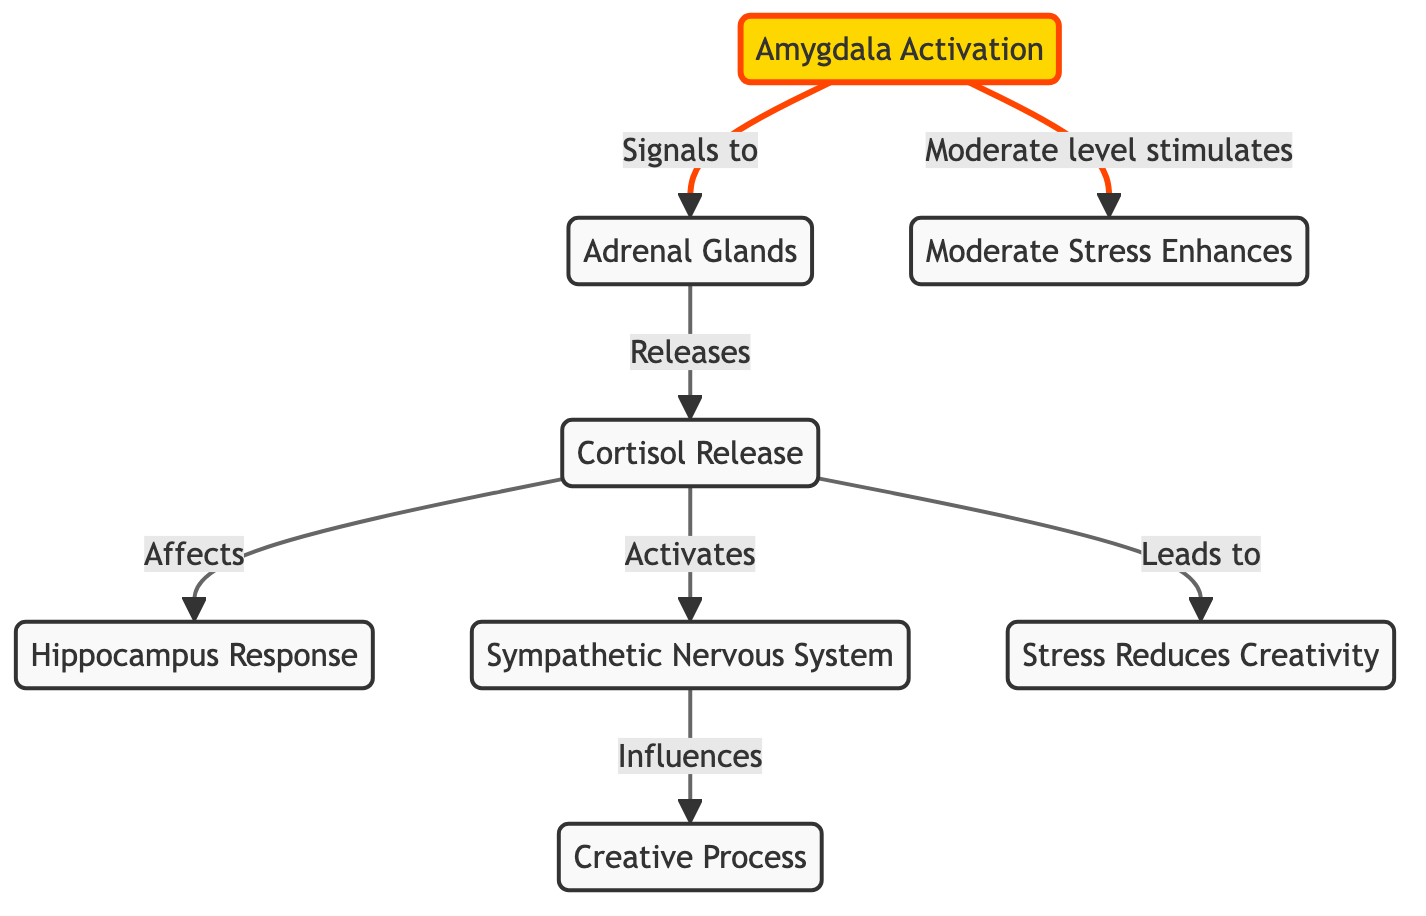What is the first node activated in this diagram? The first node activated is the amygdala, as indicated by the arrows leading from it to other nodes.
Answer: amygdala How many main nodes are in the diagram? There are six main nodes in the diagram, which include amygdala, adrenal glands, cortisol, hippocampus, sympathetic nervous system, and creative process.
Answer: six Which process is negatively influenced by cortisol according to the diagram? The process negatively influenced by cortisol is the stress reduces creativity, as directly indicated by the arrows in the diagram.
Answer: stress reduces creativity What is the relationship between the amygdala and the adrenal glands? The relationship is that the amygdala signals to the adrenal glands, leading to their activation, as noted by the directional arrow.
Answer: Signals to How does moderate stress affect creativity according to the diagram? Moderate stress enhances creativity, which is mentioned as a separate pathway influenced by the amygdala signaling at a moderate level.
Answer: Moderate Stress Enhances What role does the sympathetic nervous system play in this diagram? The sympathetic nervous system influences the creative process, connecting the stress response to artistic expression as shown in the flow of arrows.
Answer: Influences What does cortisol release lead to in the diagram? Cortisol release leads to the activation of the sympathetic nervous system and reduces creativity, as shown by two separate arrows leading from cortisol to these two outcomes.
Answer: Leads to How does the hippocampus respond to cortisol? The hippocampus responds to cortisol through the effects illustrated, indicating that cortisol affects its functioning directly.
Answer: Affects What is the connection between the amygdala and cortisol? The connection is that the amygdala signals to the adrenal glands, which then releases cortisol, demonstrating a direct flow from one to the other.
Answer: Releases 